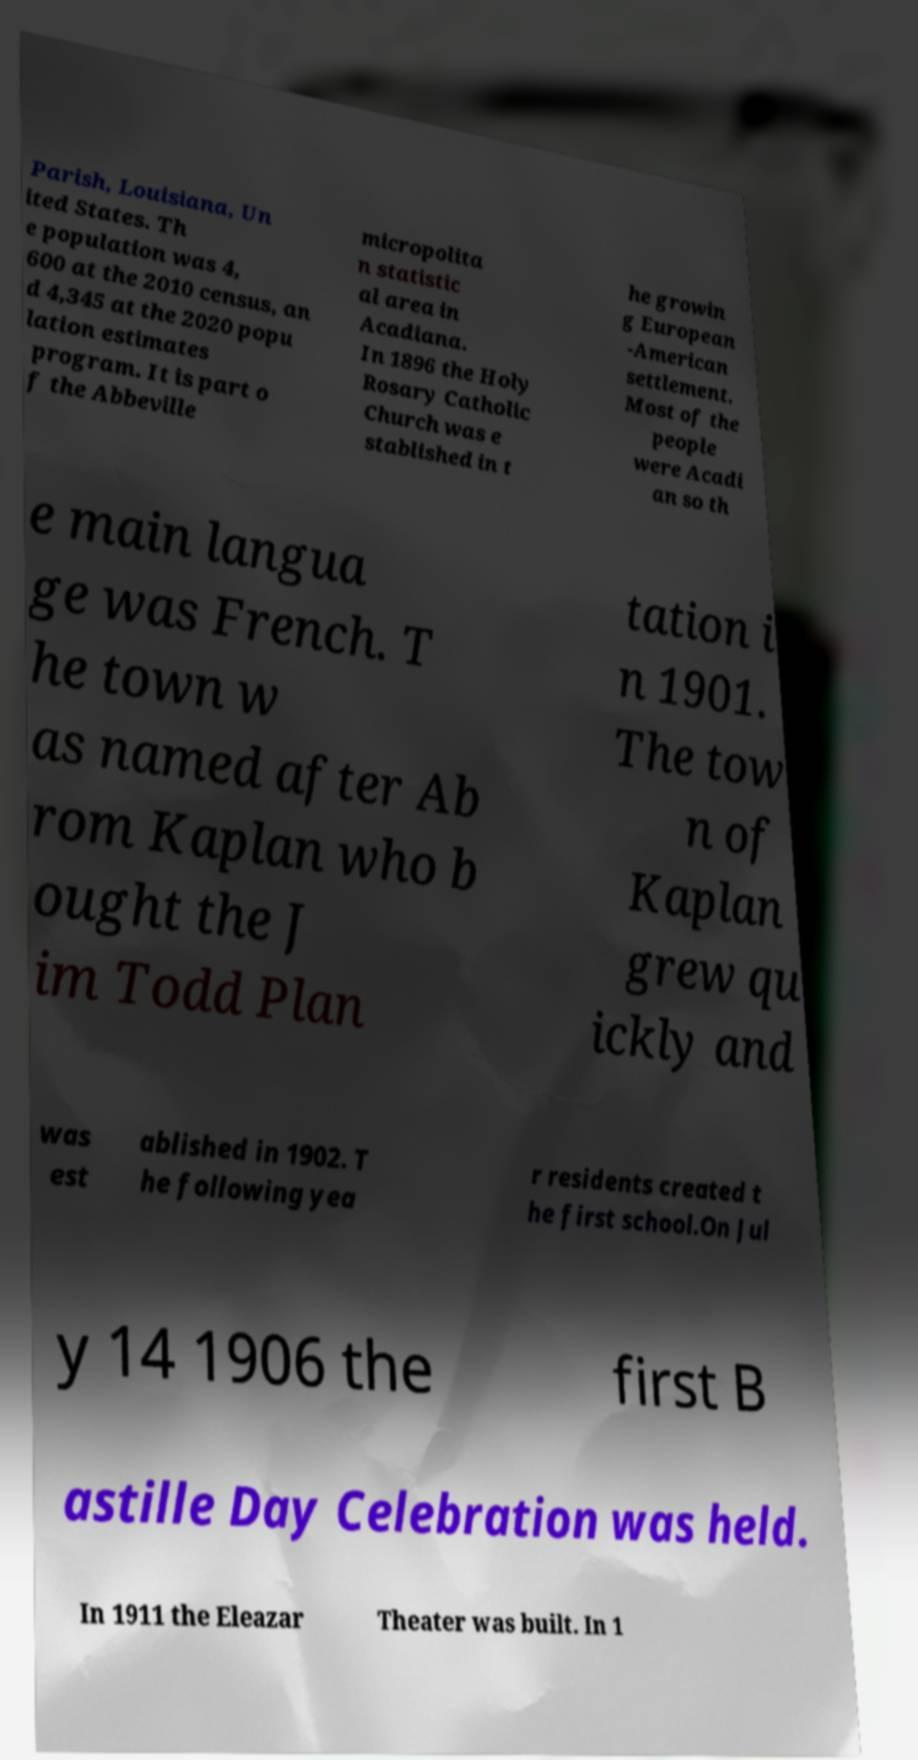For documentation purposes, I need the text within this image transcribed. Could you provide that? Parish, Louisiana, Un ited States. Th e population was 4, 600 at the 2010 census, an d 4,345 at the 2020 popu lation estimates program. It is part o f the Abbeville micropolita n statistic al area in Acadiana. In 1896 the Holy Rosary Catholic Church was e stablished in t he growin g European -American settlement. Most of the people were Acadi an so th e main langua ge was French. T he town w as named after Ab rom Kaplan who b ought the J im Todd Plan tation i n 1901. The tow n of Kaplan grew qu ickly and was est ablished in 1902. T he following yea r residents created t he first school.On Jul y 14 1906 the first B astille Day Celebration was held. In 1911 the Eleazar Theater was built. In 1 